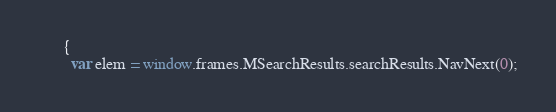Convert code to text. <code><loc_0><loc_0><loc_500><loc_500><_JavaScript_>      {
        var elem = window.frames.MSearchResults.searchResults.NavNext(0);</code> 